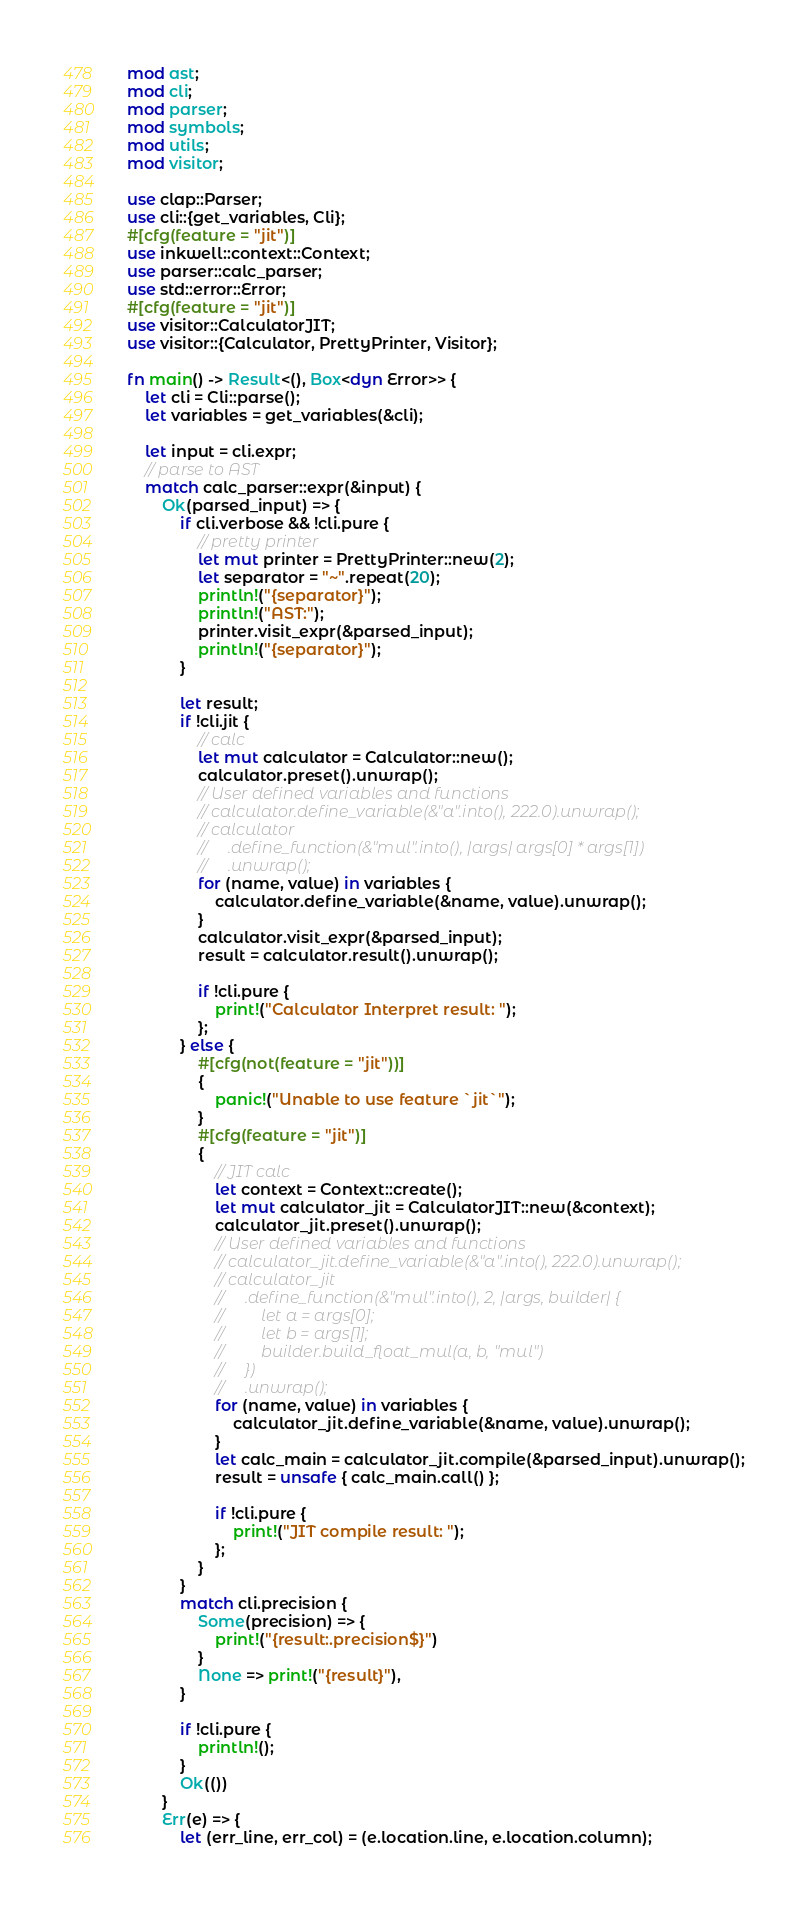<code> <loc_0><loc_0><loc_500><loc_500><_Rust_>mod ast;
mod cli;
mod parser;
mod symbols;
mod utils;
mod visitor;

use clap::Parser;
use cli::{get_variables, Cli};
#[cfg(feature = "jit")]
use inkwell::context::Context;
use parser::calc_parser;
use std::error::Error;
#[cfg(feature = "jit")]
use visitor::CalculatorJIT;
use visitor::{Calculator, PrettyPrinter, Visitor};

fn main() -> Result<(), Box<dyn Error>> {
    let cli = Cli::parse();
    let variables = get_variables(&cli);

    let input = cli.expr;
    // parse to AST
    match calc_parser::expr(&input) {
        Ok(parsed_input) => {
            if cli.verbose && !cli.pure {
                // pretty printer
                let mut printer = PrettyPrinter::new(2);
                let separator = "~".repeat(20);
                println!("{separator}");
                println!("AST:");
                printer.visit_expr(&parsed_input);
                println!("{separator}");
            }

            let result;
            if !cli.jit {
                // calc
                let mut calculator = Calculator::new();
                calculator.preset().unwrap();
                // User defined variables and functions
                // calculator.define_variable(&"a".into(), 222.0).unwrap();
                // calculator
                //     .define_function(&"mul".into(), |args| args[0] * args[1])
                //     .unwrap();
                for (name, value) in variables {
                    calculator.define_variable(&name, value).unwrap();
                }
                calculator.visit_expr(&parsed_input);
                result = calculator.result().unwrap();

                if !cli.pure {
                    print!("Calculator Interpret result: ");
                };
            } else {
                #[cfg(not(feature = "jit"))]
                {
                    panic!("Unable to use feature `jit`");
                }
                #[cfg(feature = "jit")]
                {
                    // JIT calc
                    let context = Context::create();
                    let mut calculator_jit = CalculatorJIT::new(&context);
                    calculator_jit.preset().unwrap();
                    // User defined variables and functions
                    // calculator_jit.define_variable(&"a".into(), 222.0).unwrap();
                    // calculator_jit
                    //     .define_function(&"mul".into(), 2, |args, builder| {
                    //         let a = args[0];
                    //         let b = args[1];
                    //         builder.build_float_mul(a, b, "mul")
                    //     })
                    //     .unwrap();
                    for (name, value) in variables {
                        calculator_jit.define_variable(&name, value).unwrap();
                    }
                    let calc_main = calculator_jit.compile(&parsed_input).unwrap();
                    result = unsafe { calc_main.call() };

                    if !cli.pure {
                        print!("JIT compile result: ");
                    };
                }
            }
            match cli.precision {
                Some(precision) => {
                    print!("{result:.precision$}")
                }
                None => print!("{result}"),
            }

            if !cli.pure {
                println!();
            }
            Ok(())
        }
        Err(e) => {
            let (err_line, err_col) = (e.location.line, e.location.column);</code> 